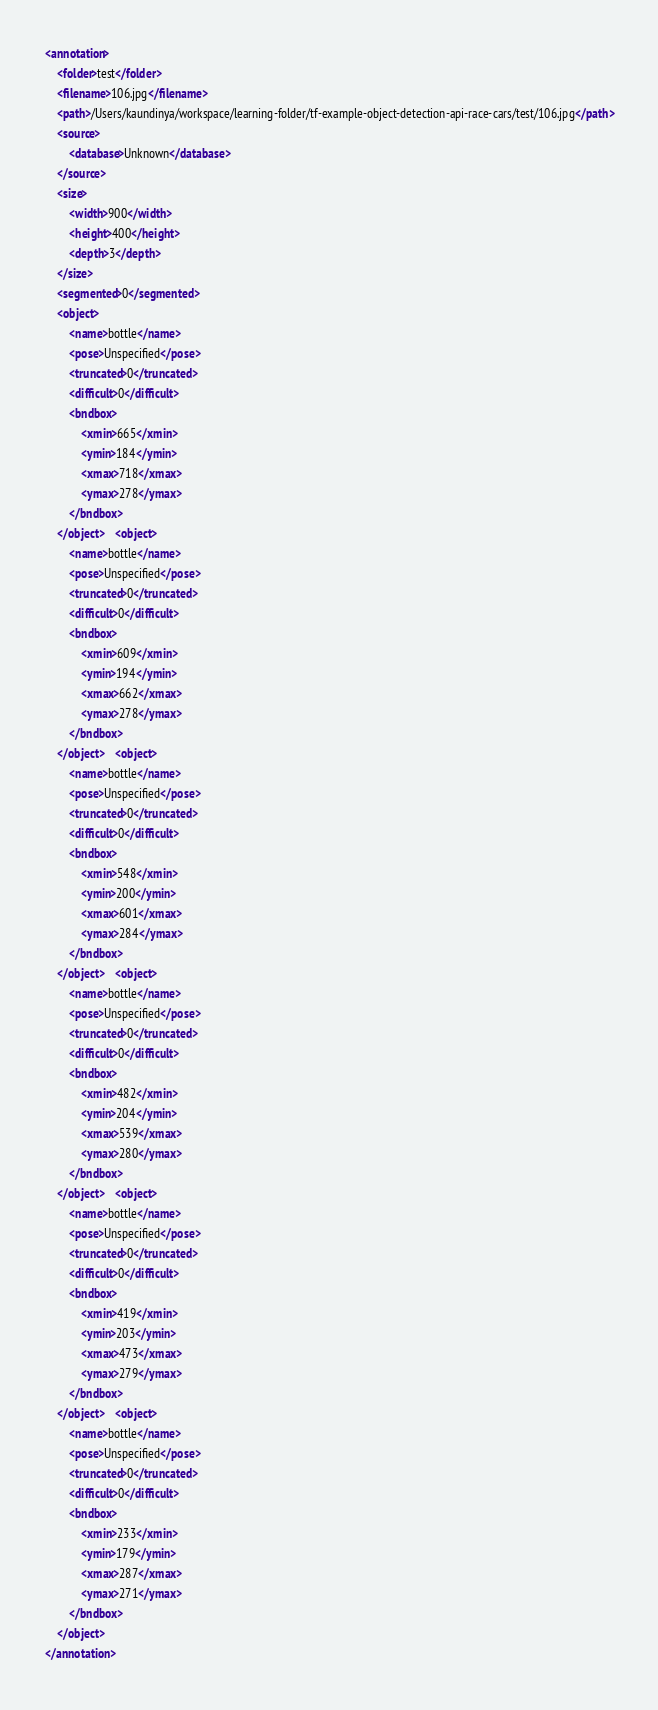<code> <loc_0><loc_0><loc_500><loc_500><_XML_><annotation>
    <folder>test</folder>
    <filename>106.jpg</filename>
    <path>/Users/kaundinya/workspace/learning-folder/tf-example-object-detection-api-race-cars/test/106.jpg</path>
    <source>
        <database>Unknown</database>
    </source>
    <size>
        <width>900</width>
        <height>400</height>
        <depth>3</depth>
    </size>
    <segmented>0</segmented>
    <object>
        <name>bottle</name>
        <pose>Unspecified</pose>
        <truncated>0</truncated>
        <difficult>0</difficult>
        <bndbox>
            <xmin>665</xmin>
            <ymin>184</ymin>
            <xmax>718</xmax>
            <ymax>278</ymax>
        </bndbox>
    </object>    <object>
        <name>bottle</name>
        <pose>Unspecified</pose>
        <truncated>0</truncated>
        <difficult>0</difficult>
        <bndbox>
            <xmin>609</xmin>
            <ymin>194</ymin>
            <xmax>662</xmax>
            <ymax>278</ymax>
        </bndbox>
    </object>    <object>
        <name>bottle</name>
        <pose>Unspecified</pose>
        <truncated>0</truncated>
        <difficult>0</difficult>
        <bndbox>
            <xmin>548</xmin>
            <ymin>200</ymin>
            <xmax>601</xmax>
            <ymax>284</ymax>
        </bndbox>
    </object>    <object>
        <name>bottle</name>
        <pose>Unspecified</pose>
        <truncated>0</truncated>
        <difficult>0</difficult>
        <bndbox>
            <xmin>482</xmin>
            <ymin>204</ymin>
            <xmax>539</xmax>
            <ymax>280</ymax>
        </bndbox>
    </object>    <object>
        <name>bottle</name>
        <pose>Unspecified</pose>
        <truncated>0</truncated>
        <difficult>0</difficult>
        <bndbox>
            <xmin>419</xmin>
            <ymin>203</ymin>
            <xmax>473</xmax>
            <ymax>279</ymax>
        </bndbox>
    </object>    <object>
        <name>bottle</name>
        <pose>Unspecified</pose>
        <truncated>0</truncated>
        <difficult>0</difficult>
        <bndbox>
            <xmin>233</xmin>
            <ymin>179</ymin>
            <xmax>287</xmax>
            <ymax>271</ymax>
        </bndbox>
    </object>
</annotation>
</code> 